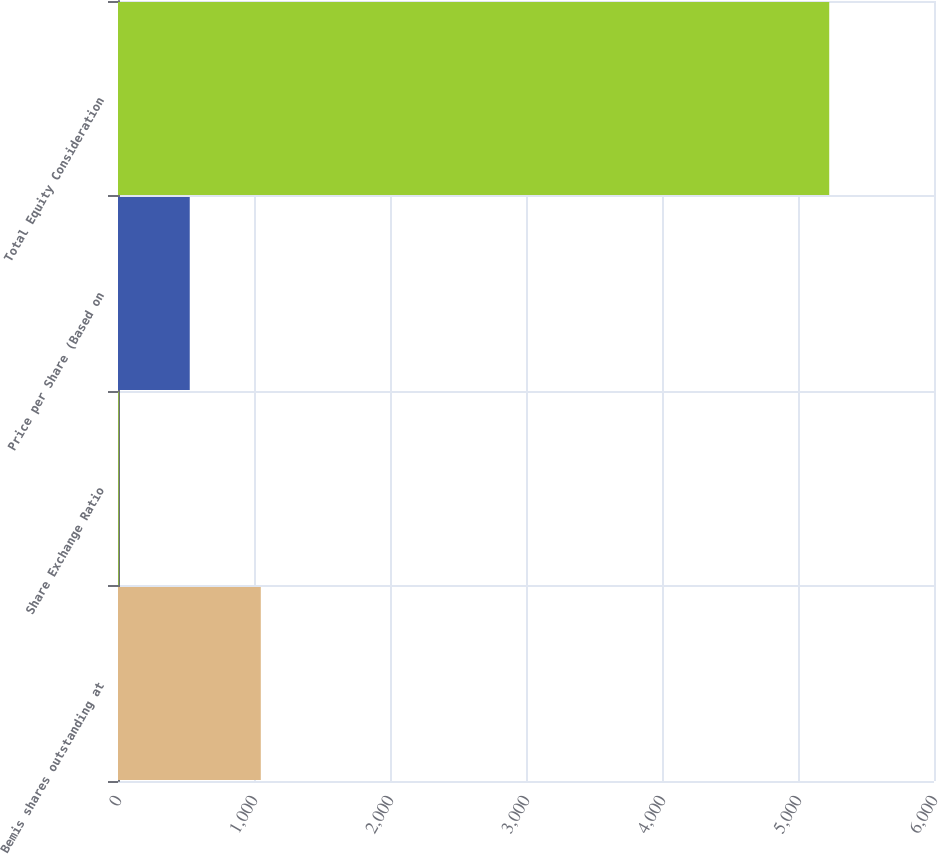Convert chart to OTSL. <chart><loc_0><loc_0><loc_500><loc_500><bar_chart><fcel>Bemis shares outstanding at<fcel>Share Exchange Ratio<fcel>Price per Share (Based on<fcel>Total Equity Consideration<nl><fcel>1050<fcel>5.1<fcel>527.55<fcel>5229.6<nl></chart> 